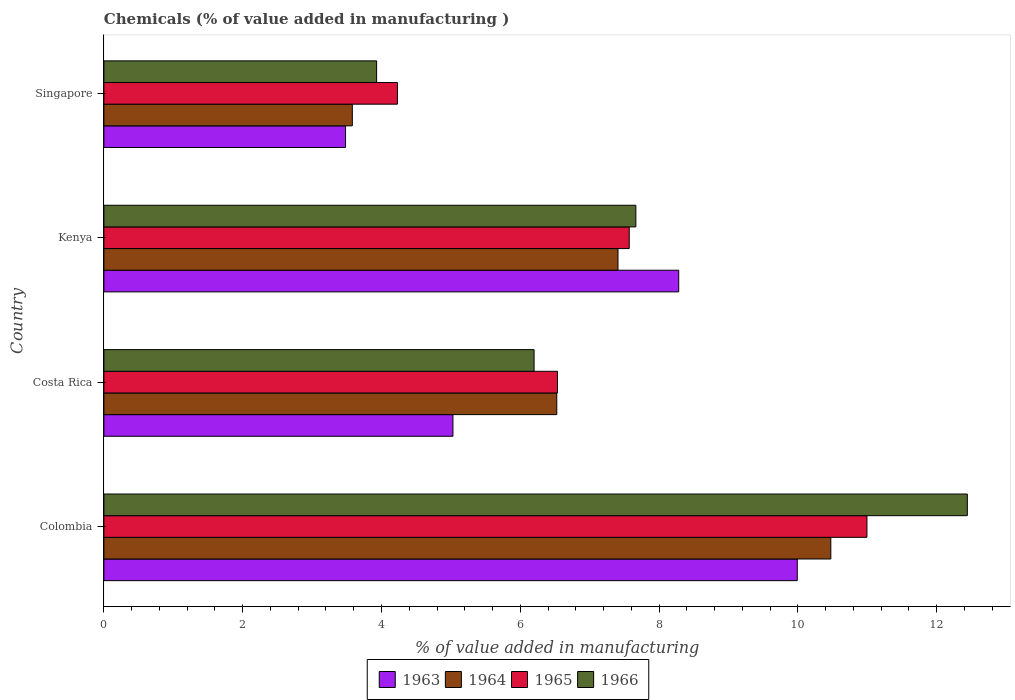How many bars are there on the 4th tick from the top?
Offer a very short reply. 4. What is the label of the 1st group of bars from the top?
Keep it short and to the point. Singapore. What is the value added in manufacturing chemicals in 1965 in Singapore?
Keep it short and to the point. 4.23. Across all countries, what is the maximum value added in manufacturing chemicals in 1963?
Ensure brevity in your answer.  9.99. Across all countries, what is the minimum value added in manufacturing chemicals in 1963?
Provide a succinct answer. 3.48. In which country was the value added in manufacturing chemicals in 1965 maximum?
Your answer should be compact. Colombia. In which country was the value added in manufacturing chemicals in 1965 minimum?
Ensure brevity in your answer.  Singapore. What is the total value added in manufacturing chemicals in 1966 in the graph?
Ensure brevity in your answer.  30.23. What is the difference between the value added in manufacturing chemicals in 1963 in Kenya and that in Singapore?
Give a very brief answer. 4.8. What is the difference between the value added in manufacturing chemicals in 1964 in Kenya and the value added in manufacturing chemicals in 1965 in Costa Rica?
Provide a succinct answer. 0.87. What is the average value added in manufacturing chemicals in 1963 per country?
Your answer should be very brief. 6.7. What is the difference between the value added in manufacturing chemicals in 1964 and value added in manufacturing chemicals in 1963 in Costa Rica?
Provide a short and direct response. 1.5. In how many countries, is the value added in manufacturing chemicals in 1964 greater than 8.4 %?
Provide a short and direct response. 1. What is the ratio of the value added in manufacturing chemicals in 1963 in Colombia to that in Singapore?
Give a very brief answer. 2.87. Is the difference between the value added in manufacturing chemicals in 1964 in Costa Rica and Kenya greater than the difference between the value added in manufacturing chemicals in 1963 in Costa Rica and Kenya?
Your answer should be compact. Yes. What is the difference between the highest and the second highest value added in manufacturing chemicals in 1963?
Your answer should be compact. 1.71. What is the difference between the highest and the lowest value added in manufacturing chemicals in 1964?
Keep it short and to the point. 6.89. What does the 2nd bar from the top in Costa Rica represents?
Provide a short and direct response. 1965. What does the 3rd bar from the bottom in Colombia represents?
Your response must be concise. 1965. How many bars are there?
Keep it short and to the point. 16. Are all the bars in the graph horizontal?
Your answer should be very brief. Yes. Does the graph contain any zero values?
Offer a very short reply. No. Where does the legend appear in the graph?
Keep it short and to the point. Bottom center. How are the legend labels stacked?
Your answer should be very brief. Horizontal. What is the title of the graph?
Keep it short and to the point. Chemicals (% of value added in manufacturing ). What is the label or title of the X-axis?
Ensure brevity in your answer.  % of value added in manufacturing. What is the label or title of the Y-axis?
Provide a short and direct response. Country. What is the % of value added in manufacturing of 1963 in Colombia?
Offer a terse response. 9.99. What is the % of value added in manufacturing of 1964 in Colombia?
Give a very brief answer. 10.47. What is the % of value added in manufacturing in 1965 in Colombia?
Your answer should be compact. 10.99. What is the % of value added in manufacturing in 1966 in Colombia?
Ensure brevity in your answer.  12.44. What is the % of value added in manufacturing of 1963 in Costa Rica?
Give a very brief answer. 5.03. What is the % of value added in manufacturing in 1964 in Costa Rica?
Ensure brevity in your answer.  6.53. What is the % of value added in manufacturing of 1965 in Costa Rica?
Ensure brevity in your answer.  6.54. What is the % of value added in manufacturing of 1966 in Costa Rica?
Ensure brevity in your answer.  6.2. What is the % of value added in manufacturing in 1963 in Kenya?
Keep it short and to the point. 8.28. What is the % of value added in manufacturing of 1964 in Kenya?
Your answer should be compact. 7.41. What is the % of value added in manufacturing in 1965 in Kenya?
Ensure brevity in your answer.  7.57. What is the % of value added in manufacturing of 1966 in Kenya?
Offer a very short reply. 7.67. What is the % of value added in manufacturing of 1963 in Singapore?
Your response must be concise. 3.48. What is the % of value added in manufacturing in 1964 in Singapore?
Offer a very short reply. 3.58. What is the % of value added in manufacturing in 1965 in Singapore?
Provide a short and direct response. 4.23. What is the % of value added in manufacturing in 1966 in Singapore?
Your response must be concise. 3.93. Across all countries, what is the maximum % of value added in manufacturing in 1963?
Provide a succinct answer. 9.99. Across all countries, what is the maximum % of value added in manufacturing of 1964?
Offer a very short reply. 10.47. Across all countries, what is the maximum % of value added in manufacturing in 1965?
Your answer should be very brief. 10.99. Across all countries, what is the maximum % of value added in manufacturing of 1966?
Offer a very short reply. 12.44. Across all countries, what is the minimum % of value added in manufacturing in 1963?
Make the answer very short. 3.48. Across all countries, what is the minimum % of value added in manufacturing of 1964?
Your answer should be very brief. 3.58. Across all countries, what is the minimum % of value added in manufacturing in 1965?
Ensure brevity in your answer.  4.23. Across all countries, what is the minimum % of value added in manufacturing in 1966?
Provide a short and direct response. 3.93. What is the total % of value added in manufacturing of 1963 in the graph?
Your answer should be very brief. 26.79. What is the total % of value added in manufacturing of 1964 in the graph?
Keep it short and to the point. 27.99. What is the total % of value added in manufacturing of 1965 in the graph?
Offer a terse response. 29.33. What is the total % of value added in manufacturing in 1966 in the graph?
Offer a very short reply. 30.23. What is the difference between the % of value added in manufacturing in 1963 in Colombia and that in Costa Rica?
Keep it short and to the point. 4.96. What is the difference between the % of value added in manufacturing of 1964 in Colombia and that in Costa Rica?
Offer a very short reply. 3.95. What is the difference between the % of value added in manufacturing in 1965 in Colombia and that in Costa Rica?
Offer a very short reply. 4.46. What is the difference between the % of value added in manufacturing of 1966 in Colombia and that in Costa Rica?
Make the answer very short. 6.24. What is the difference between the % of value added in manufacturing in 1963 in Colombia and that in Kenya?
Give a very brief answer. 1.71. What is the difference between the % of value added in manufacturing in 1964 in Colombia and that in Kenya?
Ensure brevity in your answer.  3.07. What is the difference between the % of value added in manufacturing in 1965 in Colombia and that in Kenya?
Ensure brevity in your answer.  3.43. What is the difference between the % of value added in manufacturing in 1966 in Colombia and that in Kenya?
Ensure brevity in your answer.  4.78. What is the difference between the % of value added in manufacturing in 1963 in Colombia and that in Singapore?
Offer a very short reply. 6.51. What is the difference between the % of value added in manufacturing in 1964 in Colombia and that in Singapore?
Provide a succinct answer. 6.89. What is the difference between the % of value added in manufacturing in 1965 in Colombia and that in Singapore?
Offer a terse response. 6.76. What is the difference between the % of value added in manufacturing of 1966 in Colombia and that in Singapore?
Give a very brief answer. 8.51. What is the difference between the % of value added in manufacturing in 1963 in Costa Rica and that in Kenya?
Your answer should be very brief. -3.25. What is the difference between the % of value added in manufacturing in 1964 in Costa Rica and that in Kenya?
Ensure brevity in your answer.  -0.88. What is the difference between the % of value added in manufacturing of 1965 in Costa Rica and that in Kenya?
Provide a succinct answer. -1.03. What is the difference between the % of value added in manufacturing in 1966 in Costa Rica and that in Kenya?
Ensure brevity in your answer.  -1.47. What is the difference between the % of value added in manufacturing of 1963 in Costa Rica and that in Singapore?
Your answer should be very brief. 1.55. What is the difference between the % of value added in manufacturing in 1964 in Costa Rica and that in Singapore?
Give a very brief answer. 2.95. What is the difference between the % of value added in manufacturing in 1965 in Costa Rica and that in Singapore?
Offer a very short reply. 2.31. What is the difference between the % of value added in manufacturing of 1966 in Costa Rica and that in Singapore?
Offer a terse response. 2.27. What is the difference between the % of value added in manufacturing of 1963 in Kenya and that in Singapore?
Your answer should be very brief. 4.8. What is the difference between the % of value added in manufacturing in 1964 in Kenya and that in Singapore?
Provide a short and direct response. 3.83. What is the difference between the % of value added in manufacturing of 1965 in Kenya and that in Singapore?
Offer a terse response. 3.34. What is the difference between the % of value added in manufacturing of 1966 in Kenya and that in Singapore?
Your answer should be very brief. 3.74. What is the difference between the % of value added in manufacturing in 1963 in Colombia and the % of value added in manufacturing in 1964 in Costa Rica?
Provide a short and direct response. 3.47. What is the difference between the % of value added in manufacturing of 1963 in Colombia and the % of value added in manufacturing of 1965 in Costa Rica?
Ensure brevity in your answer.  3.46. What is the difference between the % of value added in manufacturing of 1963 in Colombia and the % of value added in manufacturing of 1966 in Costa Rica?
Your answer should be very brief. 3.79. What is the difference between the % of value added in manufacturing in 1964 in Colombia and the % of value added in manufacturing in 1965 in Costa Rica?
Your answer should be compact. 3.94. What is the difference between the % of value added in manufacturing in 1964 in Colombia and the % of value added in manufacturing in 1966 in Costa Rica?
Offer a very short reply. 4.28. What is the difference between the % of value added in manufacturing of 1965 in Colombia and the % of value added in manufacturing of 1966 in Costa Rica?
Provide a short and direct response. 4.8. What is the difference between the % of value added in manufacturing in 1963 in Colombia and the % of value added in manufacturing in 1964 in Kenya?
Your answer should be very brief. 2.58. What is the difference between the % of value added in manufacturing in 1963 in Colombia and the % of value added in manufacturing in 1965 in Kenya?
Offer a terse response. 2.42. What is the difference between the % of value added in manufacturing in 1963 in Colombia and the % of value added in manufacturing in 1966 in Kenya?
Keep it short and to the point. 2.33. What is the difference between the % of value added in manufacturing in 1964 in Colombia and the % of value added in manufacturing in 1965 in Kenya?
Provide a succinct answer. 2.9. What is the difference between the % of value added in manufacturing of 1964 in Colombia and the % of value added in manufacturing of 1966 in Kenya?
Provide a short and direct response. 2.81. What is the difference between the % of value added in manufacturing in 1965 in Colombia and the % of value added in manufacturing in 1966 in Kenya?
Your response must be concise. 3.33. What is the difference between the % of value added in manufacturing in 1963 in Colombia and the % of value added in manufacturing in 1964 in Singapore?
Ensure brevity in your answer.  6.41. What is the difference between the % of value added in manufacturing of 1963 in Colombia and the % of value added in manufacturing of 1965 in Singapore?
Provide a short and direct response. 5.76. What is the difference between the % of value added in manufacturing in 1963 in Colombia and the % of value added in manufacturing in 1966 in Singapore?
Your response must be concise. 6.06. What is the difference between the % of value added in manufacturing in 1964 in Colombia and the % of value added in manufacturing in 1965 in Singapore?
Provide a succinct answer. 6.24. What is the difference between the % of value added in manufacturing in 1964 in Colombia and the % of value added in manufacturing in 1966 in Singapore?
Keep it short and to the point. 6.54. What is the difference between the % of value added in manufacturing in 1965 in Colombia and the % of value added in manufacturing in 1966 in Singapore?
Offer a very short reply. 7.07. What is the difference between the % of value added in manufacturing of 1963 in Costa Rica and the % of value added in manufacturing of 1964 in Kenya?
Ensure brevity in your answer.  -2.38. What is the difference between the % of value added in manufacturing of 1963 in Costa Rica and the % of value added in manufacturing of 1965 in Kenya?
Your answer should be very brief. -2.54. What is the difference between the % of value added in manufacturing in 1963 in Costa Rica and the % of value added in manufacturing in 1966 in Kenya?
Your response must be concise. -2.64. What is the difference between the % of value added in manufacturing in 1964 in Costa Rica and the % of value added in manufacturing in 1965 in Kenya?
Make the answer very short. -1.04. What is the difference between the % of value added in manufacturing in 1964 in Costa Rica and the % of value added in manufacturing in 1966 in Kenya?
Offer a terse response. -1.14. What is the difference between the % of value added in manufacturing in 1965 in Costa Rica and the % of value added in manufacturing in 1966 in Kenya?
Your response must be concise. -1.13. What is the difference between the % of value added in manufacturing in 1963 in Costa Rica and the % of value added in manufacturing in 1964 in Singapore?
Your answer should be very brief. 1.45. What is the difference between the % of value added in manufacturing in 1963 in Costa Rica and the % of value added in manufacturing in 1965 in Singapore?
Ensure brevity in your answer.  0.8. What is the difference between the % of value added in manufacturing in 1963 in Costa Rica and the % of value added in manufacturing in 1966 in Singapore?
Your answer should be very brief. 1.1. What is the difference between the % of value added in manufacturing of 1964 in Costa Rica and the % of value added in manufacturing of 1965 in Singapore?
Offer a very short reply. 2.3. What is the difference between the % of value added in manufacturing of 1964 in Costa Rica and the % of value added in manufacturing of 1966 in Singapore?
Your response must be concise. 2.6. What is the difference between the % of value added in manufacturing in 1965 in Costa Rica and the % of value added in manufacturing in 1966 in Singapore?
Offer a terse response. 2.61. What is the difference between the % of value added in manufacturing in 1963 in Kenya and the % of value added in manufacturing in 1964 in Singapore?
Make the answer very short. 4.7. What is the difference between the % of value added in manufacturing of 1963 in Kenya and the % of value added in manufacturing of 1965 in Singapore?
Your answer should be compact. 4.05. What is the difference between the % of value added in manufacturing of 1963 in Kenya and the % of value added in manufacturing of 1966 in Singapore?
Offer a terse response. 4.35. What is the difference between the % of value added in manufacturing of 1964 in Kenya and the % of value added in manufacturing of 1965 in Singapore?
Offer a terse response. 3.18. What is the difference between the % of value added in manufacturing in 1964 in Kenya and the % of value added in manufacturing in 1966 in Singapore?
Your answer should be very brief. 3.48. What is the difference between the % of value added in manufacturing of 1965 in Kenya and the % of value added in manufacturing of 1966 in Singapore?
Offer a terse response. 3.64. What is the average % of value added in manufacturing in 1963 per country?
Offer a very short reply. 6.7. What is the average % of value added in manufacturing of 1964 per country?
Your answer should be very brief. 7. What is the average % of value added in manufacturing of 1965 per country?
Your answer should be compact. 7.33. What is the average % of value added in manufacturing of 1966 per country?
Provide a succinct answer. 7.56. What is the difference between the % of value added in manufacturing of 1963 and % of value added in manufacturing of 1964 in Colombia?
Offer a very short reply. -0.48. What is the difference between the % of value added in manufacturing in 1963 and % of value added in manufacturing in 1965 in Colombia?
Your answer should be compact. -1. What is the difference between the % of value added in manufacturing in 1963 and % of value added in manufacturing in 1966 in Colombia?
Ensure brevity in your answer.  -2.45. What is the difference between the % of value added in manufacturing of 1964 and % of value added in manufacturing of 1965 in Colombia?
Keep it short and to the point. -0.52. What is the difference between the % of value added in manufacturing in 1964 and % of value added in manufacturing in 1966 in Colombia?
Offer a very short reply. -1.97. What is the difference between the % of value added in manufacturing in 1965 and % of value added in manufacturing in 1966 in Colombia?
Offer a very short reply. -1.45. What is the difference between the % of value added in manufacturing in 1963 and % of value added in manufacturing in 1964 in Costa Rica?
Offer a terse response. -1.5. What is the difference between the % of value added in manufacturing of 1963 and % of value added in manufacturing of 1965 in Costa Rica?
Provide a succinct answer. -1.51. What is the difference between the % of value added in manufacturing of 1963 and % of value added in manufacturing of 1966 in Costa Rica?
Your response must be concise. -1.17. What is the difference between the % of value added in manufacturing of 1964 and % of value added in manufacturing of 1965 in Costa Rica?
Your answer should be compact. -0.01. What is the difference between the % of value added in manufacturing in 1964 and % of value added in manufacturing in 1966 in Costa Rica?
Make the answer very short. 0.33. What is the difference between the % of value added in manufacturing in 1965 and % of value added in manufacturing in 1966 in Costa Rica?
Offer a very short reply. 0.34. What is the difference between the % of value added in manufacturing of 1963 and % of value added in manufacturing of 1964 in Kenya?
Ensure brevity in your answer.  0.87. What is the difference between the % of value added in manufacturing in 1963 and % of value added in manufacturing in 1965 in Kenya?
Offer a very short reply. 0.71. What is the difference between the % of value added in manufacturing in 1963 and % of value added in manufacturing in 1966 in Kenya?
Offer a very short reply. 0.62. What is the difference between the % of value added in manufacturing of 1964 and % of value added in manufacturing of 1965 in Kenya?
Your response must be concise. -0.16. What is the difference between the % of value added in manufacturing of 1964 and % of value added in manufacturing of 1966 in Kenya?
Offer a very short reply. -0.26. What is the difference between the % of value added in manufacturing in 1965 and % of value added in manufacturing in 1966 in Kenya?
Your response must be concise. -0.1. What is the difference between the % of value added in manufacturing of 1963 and % of value added in manufacturing of 1964 in Singapore?
Provide a short and direct response. -0.1. What is the difference between the % of value added in manufacturing of 1963 and % of value added in manufacturing of 1965 in Singapore?
Give a very brief answer. -0.75. What is the difference between the % of value added in manufacturing in 1963 and % of value added in manufacturing in 1966 in Singapore?
Keep it short and to the point. -0.45. What is the difference between the % of value added in manufacturing of 1964 and % of value added in manufacturing of 1965 in Singapore?
Give a very brief answer. -0.65. What is the difference between the % of value added in manufacturing in 1964 and % of value added in manufacturing in 1966 in Singapore?
Keep it short and to the point. -0.35. What is the difference between the % of value added in manufacturing in 1965 and % of value added in manufacturing in 1966 in Singapore?
Keep it short and to the point. 0.3. What is the ratio of the % of value added in manufacturing in 1963 in Colombia to that in Costa Rica?
Give a very brief answer. 1.99. What is the ratio of the % of value added in manufacturing of 1964 in Colombia to that in Costa Rica?
Your answer should be very brief. 1.61. What is the ratio of the % of value added in manufacturing of 1965 in Colombia to that in Costa Rica?
Provide a short and direct response. 1.68. What is the ratio of the % of value added in manufacturing in 1966 in Colombia to that in Costa Rica?
Offer a terse response. 2.01. What is the ratio of the % of value added in manufacturing of 1963 in Colombia to that in Kenya?
Offer a terse response. 1.21. What is the ratio of the % of value added in manufacturing in 1964 in Colombia to that in Kenya?
Your answer should be very brief. 1.41. What is the ratio of the % of value added in manufacturing in 1965 in Colombia to that in Kenya?
Keep it short and to the point. 1.45. What is the ratio of the % of value added in manufacturing of 1966 in Colombia to that in Kenya?
Provide a short and direct response. 1.62. What is the ratio of the % of value added in manufacturing of 1963 in Colombia to that in Singapore?
Keep it short and to the point. 2.87. What is the ratio of the % of value added in manufacturing in 1964 in Colombia to that in Singapore?
Your answer should be very brief. 2.93. What is the ratio of the % of value added in manufacturing of 1965 in Colombia to that in Singapore?
Make the answer very short. 2.6. What is the ratio of the % of value added in manufacturing of 1966 in Colombia to that in Singapore?
Your answer should be very brief. 3.17. What is the ratio of the % of value added in manufacturing of 1963 in Costa Rica to that in Kenya?
Make the answer very short. 0.61. What is the ratio of the % of value added in manufacturing in 1964 in Costa Rica to that in Kenya?
Provide a short and direct response. 0.88. What is the ratio of the % of value added in manufacturing in 1965 in Costa Rica to that in Kenya?
Provide a short and direct response. 0.86. What is the ratio of the % of value added in manufacturing of 1966 in Costa Rica to that in Kenya?
Your answer should be compact. 0.81. What is the ratio of the % of value added in manufacturing in 1963 in Costa Rica to that in Singapore?
Your response must be concise. 1.44. What is the ratio of the % of value added in manufacturing of 1964 in Costa Rica to that in Singapore?
Provide a succinct answer. 1.82. What is the ratio of the % of value added in manufacturing in 1965 in Costa Rica to that in Singapore?
Your answer should be very brief. 1.55. What is the ratio of the % of value added in manufacturing in 1966 in Costa Rica to that in Singapore?
Your answer should be very brief. 1.58. What is the ratio of the % of value added in manufacturing of 1963 in Kenya to that in Singapore?
Your response must be concise. 2.38. What is the ratio of the % of value added in manufacturing in 1964 in Kenya to that in Singapore?
Your answer should be very brief. 2.07. What is the ratio of the % of value added in manufacturing of 1965 in Kenya to that in Singapore?
Keep it short and to the point. 1.79. What is the ratio of the % of value added in manufacturing in 1966 in Kenya to that in Singapore?
Provide a succinct answer. 1.95. What is the difference between the highest and the second highest % of value added in manufacturing of 1963?
Keep it short and to the point. 1.71. What is the difference between the highest and the second highest % of value added in manufacturing in 1964?
Your answer should be very brief. 3.07. What is the difference between the highest and the second highest % of value added in manufacturing of 1965?
Offer a very short reply. 3.43. What is the difference between the highest and the second highest % of value added in manufacturing of 1966?
Keep it short and to the point. 4.78. What is the difference between the highest and the lowest % of value added in manufacturing in 1963?
Provide a succinct answer. 6.51. What is the difference between the highest and the lowest % of value added in manufacturing in 1964?
Keep it short and to the point. 6.89. What is the difference between the highest and the lowest % of value added in manufacturing of 1965?
Provide a succinct answer. 6.76. What is the difference between the highest and the lowest % of value added in manufacturing in 1966?
Make the answer very short. 8.51. 